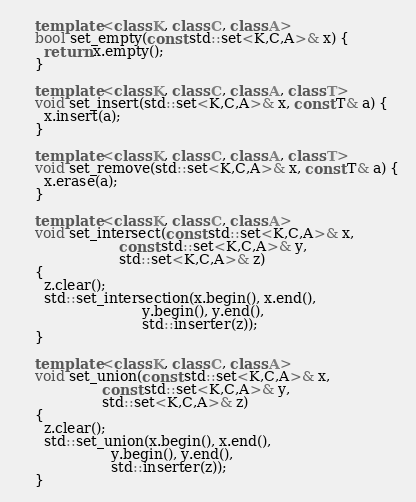<code> <loc_0><loc_0><loc_500><loc_500><_C++_>    template <class K, class C, class A>
    bool set_empty(const std::set<K,C,A>& x) {
      return x.empty();
    }

    template <class K, class C, class A, class T>
    void set_insert(std::set<K,C,A>& x, const T& a) {
      x.insert(a);
    }

    template <class K, class C, class A, class T>
    void set_remove(std::set<K,C,A>& x, const T& a) {
      x.erase(a);
    }
    
    template <class K, class C, class A>
    void set_intersect(const std::set<K,C,A>& x,
                       const std::set<K,C,A>& y,
                       std::set<K,C,A>& z)
    {
      z.clear();
      std::set_intersection(x.begin(), x.end(),
                            y.begin(), y.end(),
                            std::inserter(z));
    }

    template <class K, class C, class A>
    void set_union(const std::set<K,C,A>& x,
                   const std::set<K,C,A>& y,
                   std::set<K,C,A>& z)
    {
      z.clear();
      std::set_union(x.begin(), x.end(),
                     y.begin(), y.end(),
                     std::inserter(z));
    }
</code> 